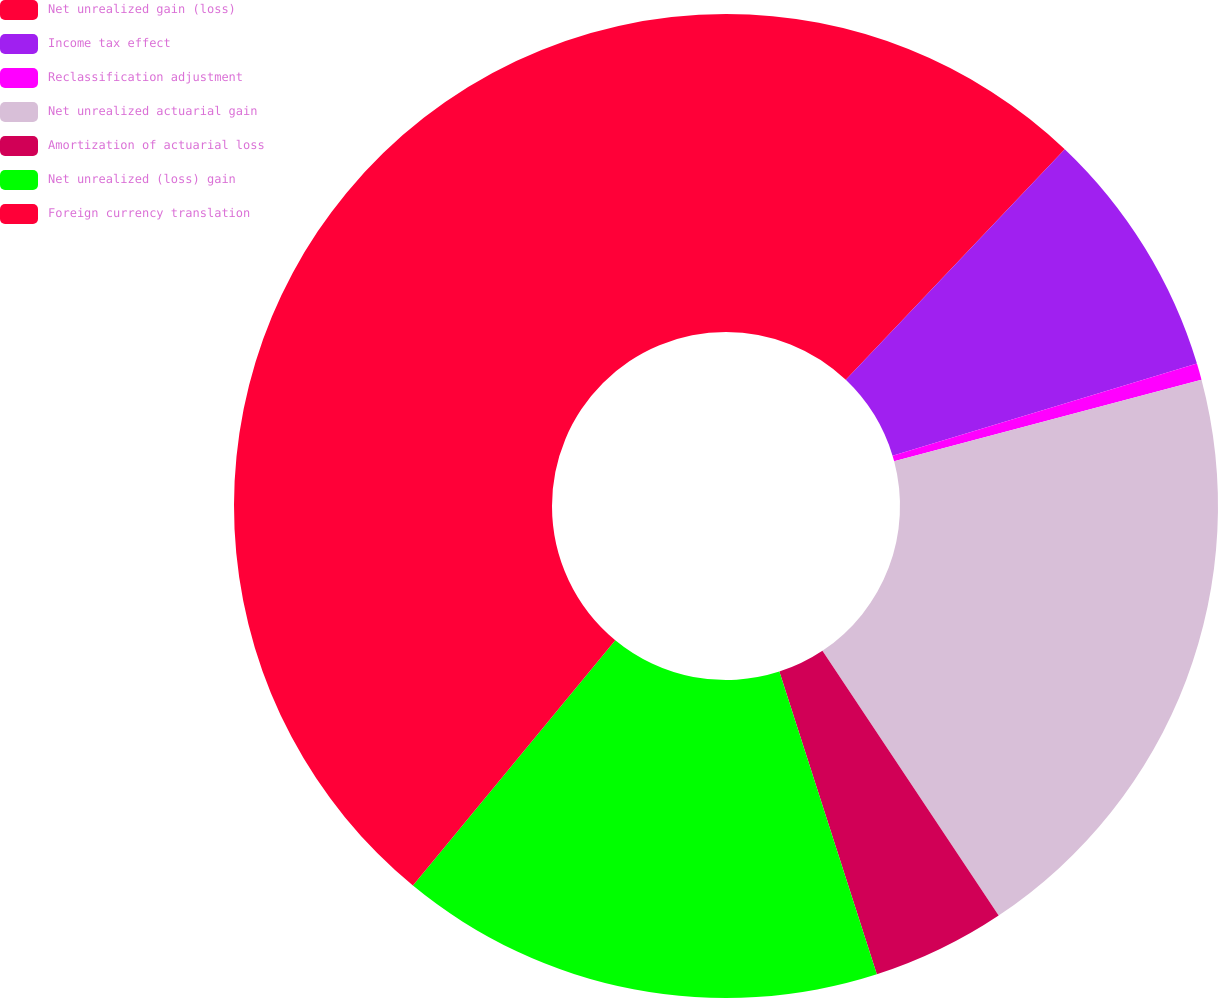Convert chart to OTSL. <chart><loc_0><loc_0><loc_500><loc_500><pie_chart><fcel>Net unrealized gain (loss)<fcel>Income tax effect<fcel>Reclassification adjustment<fcel>Net unrealized actuarial gain<fcel>Amortization of actuarial loss<fcel>Net unrealized (loss) gain<fcel>Foreign currency translation<nl><fcel>12.09%<fcel>8.24%<fcel>0.54%<fcel>19.79%<fcel>4.39%<fcel>15.94%<fcel>39.03%<nl></chart> 